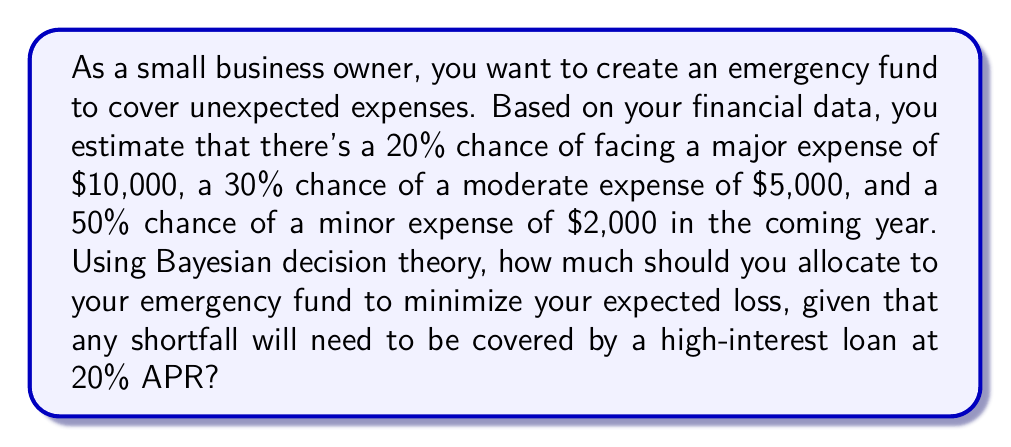Solve this math problem. To solve this problem, we'll use Bayesian decision theory to calculate the expected loss for different allocation amounts and choose the one that minimizes the loss.

Let's define our possible states and their probabilities:
1. Major expense: $P(M) = 0.20$, Cost = $10,000
2. Moderate expense: $P(D) = 0.30$, Cost = $5,000
3. Minor expense: $P(N) = 0.50$, Cost = $2,000

We'll consider allocation amounts in increments of $1,000 from $0 to $10,000.

For each allocation amount $A$, we calculate the expected loss $E(L)$ as follows:

$$E(L) = P(M) \cdot L(M,A) + P(D) \cdot L(D,A) + P(N) \cdot L(N,A)$$

Where $L(S,A)$ is the loss function for state $S$ and allocation $A$:

$$L(S,A) = \begin{cases}
0 & \text{if } A \geq \text{Cost}(S) \\
(\text{Cost}(S) - A) \cdot 1.20 & \text{if } A < \text{Cost}(S)
\end{cases}$$

The 1.20 factor accounts for the 20% APR on the loan for any shortfall.

Let's calculate $E(L)$ for each allocation:

1. $A = 0$:
   $E(L) = 0.20 \cdot (10000 \cdot 1.20) + 0.30 \cdot (5000 \cdot 1.20) + 0.50 \cdot (2000 \cdot 1.20) = 4800$

2. $A = 1000$:
   $E(L) = 0.20 \cdot (9000 \cdot 1.20) + 0.30 \cdot (4000 \cdot 1.20) + 0.50 \cdot (1000 \cdot 1.20) = 3960$

3. $A = 2000$:
   $E(L) = 0.20 \cdot (8000 \cdot 1.20) + 0.30 \cdot (3000 \cdot 1.20) + 0.50 \cdot 0 = 3120$

4. $A = 3000$:
   $E(L) = 0.20 \cdot (7000 \cdot 1.20) + 0.30 \cdot (2000 \cdot 1.20) + 0.50 \cdot 0 = 2520$

5. $A = 4000$:
   $E(L) = 0.20 \cdot (6000 \cdot 1.20) + 0.30 \cdot (1000 \cdot 1.20) + 0.50 \cdot 0 = 1920$

6. $A = 5000$:
   $E(L) = 0.20 \cdot (5000 \cdot 1.20) + 0.30 \cdot 0 + 0.50 \cdot 0 = 1200$

7. $A = 6000$:
   $E(L) = 0.20 \cdot (4000 \cdot 1.20) + 0.30 \cdot 0 + 0.50 \cdot 0 = 960$

8. $A = 7000$:
   $E(L) = 0.20 \cdot (3000 \cdot 1.20) + 0.30 \cdot 0 + 0.50 \cdot 0 = 720$

9. $A = 8000$:
   $E(L) = 0.20 \cdot (2000 \cdot 1.20) + 0.30 \cdot 0 + 0.50 \cdot 0 = 480$

10. $A = 9000$:
    $E(L) = 0.20 \cdot (1000 \cdot 1.20) + 0.30 \cdot 0 + 0.50 \cdot 0 = 240$

11. $A = 10000$:
    $E(L) = 0.20 \cdot 0 + 0.30 \cdot 0 + 0.50 \cdot 0 = 0$

The allocation that minimizes the expected loss is $10,000.
Answer: $10,000 